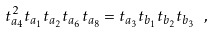Convert formula to latex. <formula><loc_0><loc_0><loc_500><loc_500>t _ { a _ { 4 } } ^ { 2 } t _ { a _ { 1 } } t _ { a _ { 2 } } t _ { a _ { 6 } } t _ { a _ { 8 } } = t _ { a _ { 3 } } t _ { b _ { 1 } } t _ { b _ { 2 } } t _ { b _ { 3 } } \ ,</formula> 